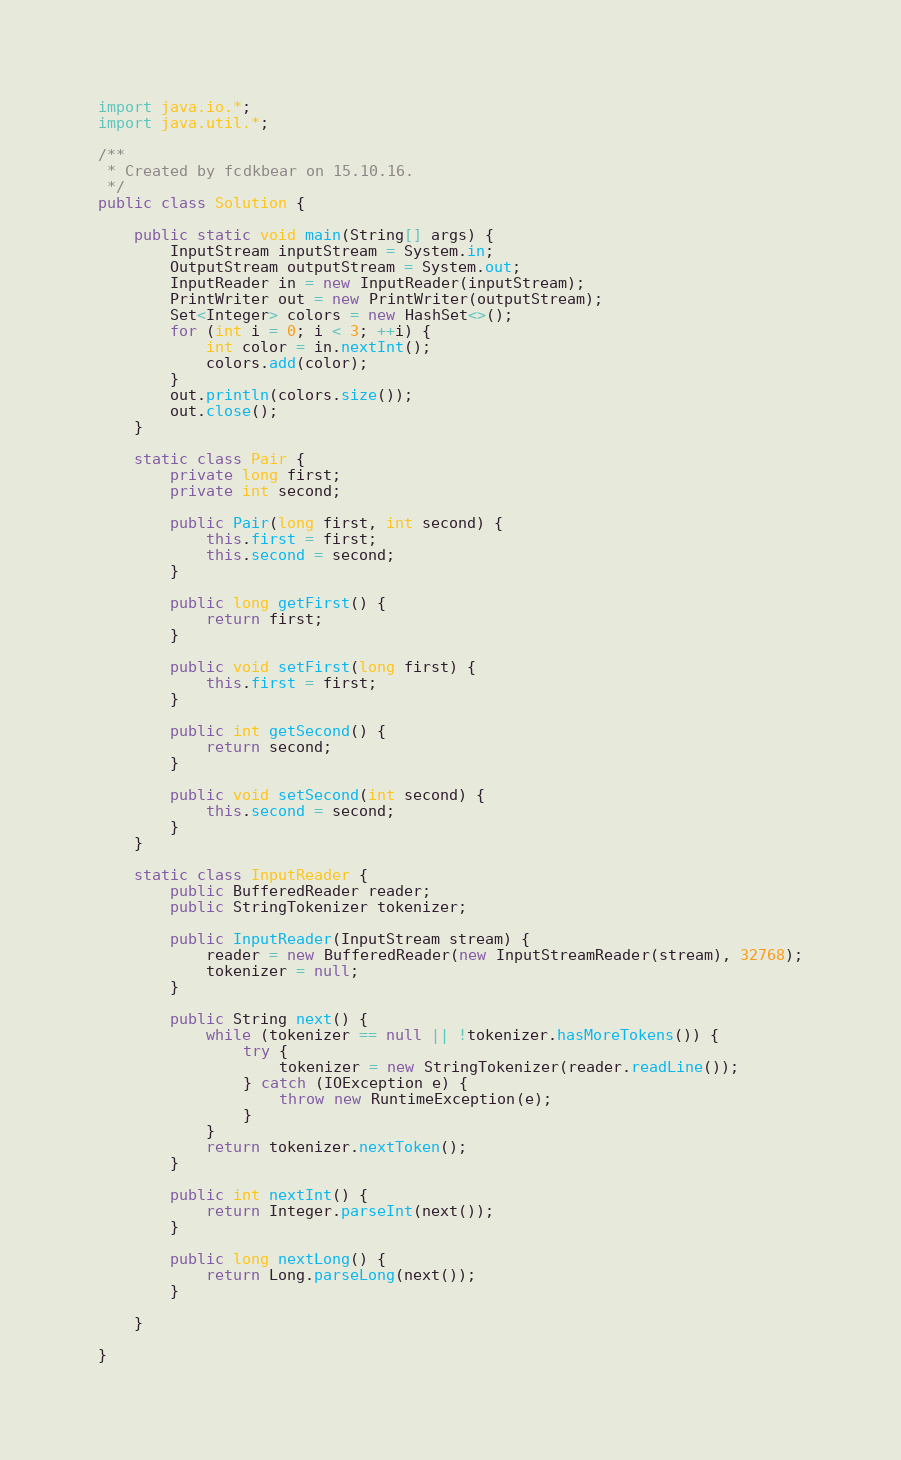<code> <loc_0><loc_0><loc_500><loc_500><_Java_>import java.io.*;
import java.util.*;

/**
 * Created by fcdkbear on 15.10.16.
 */
public class Solution {

    public static void main(String[] args) {
        InputStream inputStream = System.in;
        OutputStream outputStream = System.out;
        InputReader in = new InputReader(inputStream);
        PrintWriter out = new PrintWriter(outputStream);
        Set<Integer> colors = new HashSet<>();
        for (int i = 0; i < 3; ++i) {
            int color = in.nextInt();
            colors.add(color);
        }
        out.println(colors.size());
        out.close();
    }

    static class Pair {
        private long first;
        private int second;

        public Pair(long first, int second) {
            this.first = first;
            this.second = second;
        }

        public long getFirst() {
            return first;
        }

        public void setFirst(long first) {
            this.first = first;
        }

        public int getSecond() {
            return second;
        }

        public void setSecond(int second) {
            this.second = second;
        }
    }

    static class InputReader {
        public BufferedReader reader;
        public StringTokenizer tokenizer;

        public InputReader(InputStream stream) {
            reader = new BufferedReader(new InputStreamReader(stream), 32768);
            tokenizer = null;
        }

        public String next() {
            while (tokenizer == null || !tokenizer.hasMoreTokens()) {
                try {
                    tokenizer = new StringTokenizer(reader.readLine());
                } catch (IOException e) {
                    throw new RuntimeException(e);
                }
            }
            return tokenizer.nextToken();
        }

        public int nextInt() {
            return Integer.parseInt(next());
        }

        public long nextLong() {
            return Long.parseLong(next());
        }

    }

}
</code> 